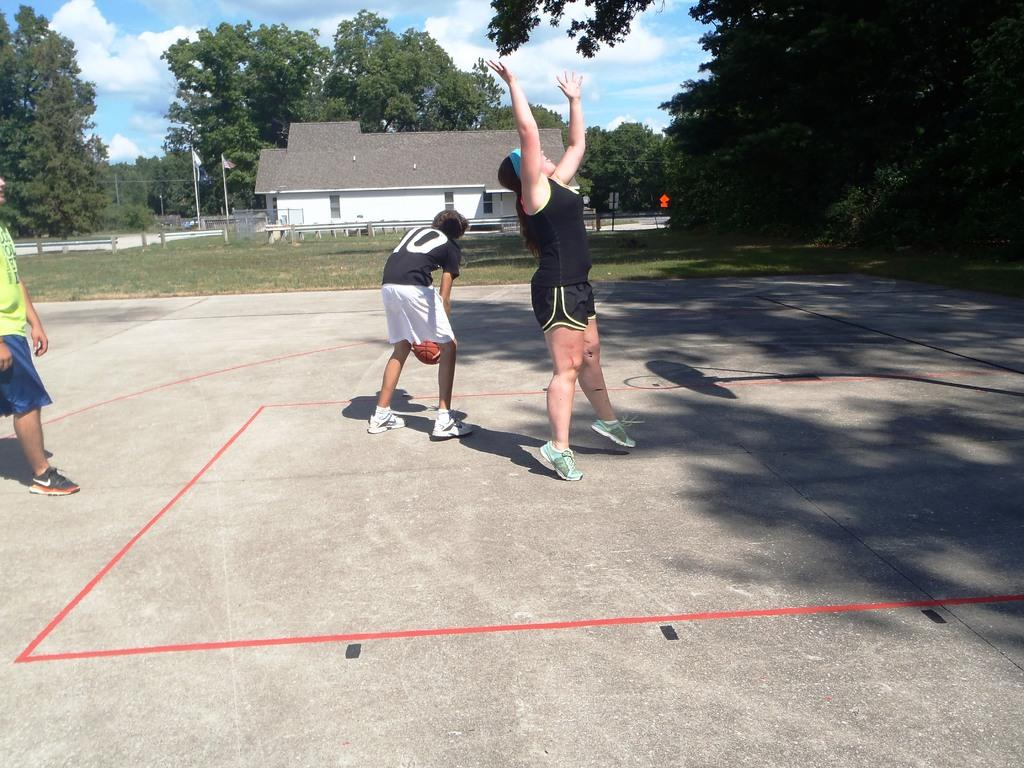What activity are the people in the image engaged in? The people in the image are playing basketball. What surface are they playing on? The basketball court is visible in the image. What can be seen in the background of the image? There is a house, trees, and the sky visible in the background of the image. What is the condition of the sky in the image? Clouds are visible in the sky. What type of crime is being committed in the image? There is no crime being committed in the image; it features people playing basketball on a court. What flag is being waved by the players in the image? There is no flag present in the image; it only shows people playing basketball on a court. 